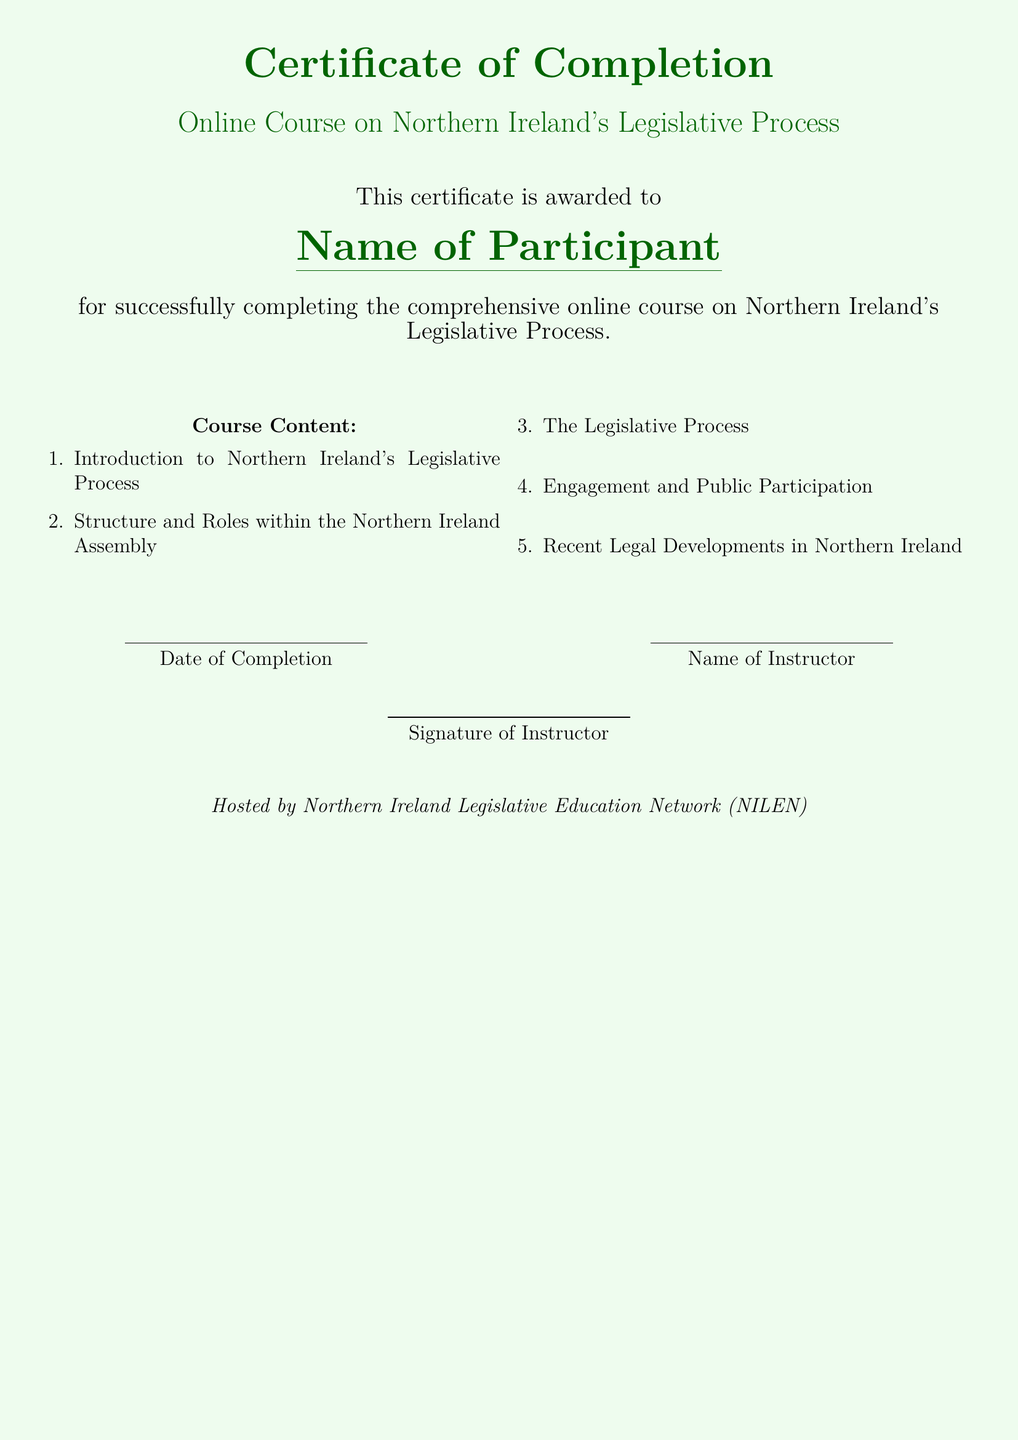What is the title of the course? The title of the course is stated clearly in the document as "Online Course on Northern Ireland's Legislative Process."
Answer: Online Course on Northern Ireland's Legislative Process Who is the certificate awarded to? The document indicates that the certificate is awarded to the "Name of Participant," which is a placeholder for the actual name.
Answer: Name of Participant What is the date format used in the document? The document provides a section labeled "Date of Completion," indicating that the date appears under this heading.
Answer: Date of Completion What color is used for the background of the certificate? The document specifies the background color as "lightgreen!15", which refers to a light green shade.
Answer: lightgreen How many items are listed in the course content? The document outlines five specific items in the course content section, as denoted by the enumerate environment.
Answer: 5 Who is associated with the signature on the certificate? The certificate mentions a placeholder for "Name of Instructor," indicating who will sign the document.
Answer: Name of Instructor What organization hosted the course? The document concludes with the statement "Hosted by Northern Ireland Legislative Education Network (NILEN)", identifying the hosting organization.
Answer: Northern Ireland Legislative Education Network (NILEN) What is detailed in the "Course Content" section? The "Course Content" section lists topics covered in the course, which include important aspects of Northern Ireland's Legislative Process.
Answer: Introduction to Northern Ireland's Legislative Process, Structure and Roles within the Northern Ireland Assembly, The Legislative Process, Engagement and Public Participation, Recent Legal Developments in Northern Ireland 